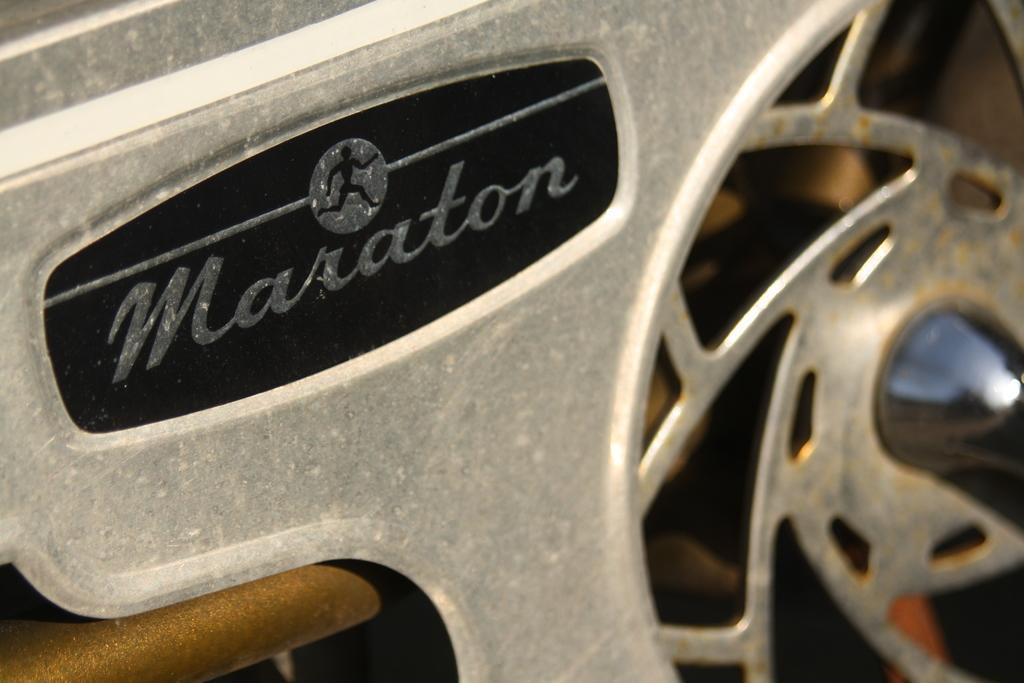Could you give a brief overview of what you see in this image? Here we can see meta object and this metal object we can see a person logo. 